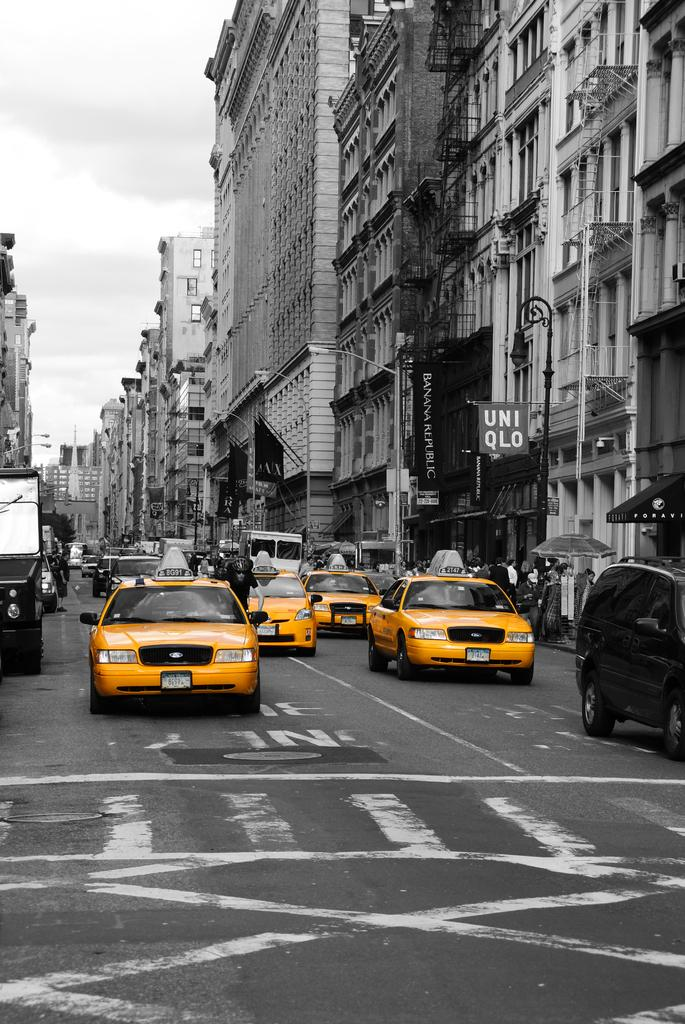What is happening in the foreground of the image? There are vehicles moving on the road in the foreground of the image. What can be seen in the background of the image? There are buildings, poles, flags, and banners in the background of the image. What is visible in the sky in the image? The sky is visible in the background of the image. Can you see a bone hanging from the pole in the image? There is no bone present in the image; only poles, flags, and banners are visible. How many boots are visible on the vehicles in the image? There is no mention of boots in the image; the focus is on the vehicles, buildings, and background elements. 